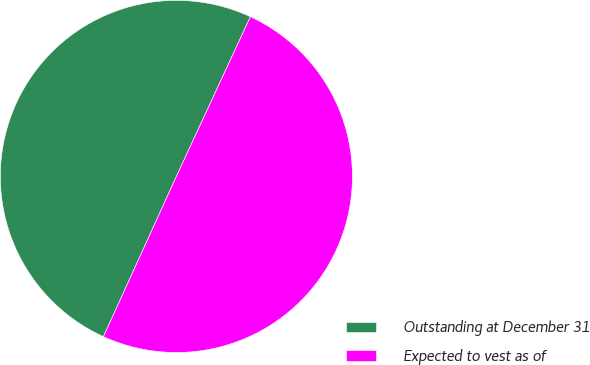Convert chart. <chart><loc_0><loc_0><loc_500><loc_500><pie_chart><fcel>Outstanding at December 31<fcel>Expected to vest as of<nl><fcel>50.11%<fcel>49.89%<nl></chart> 